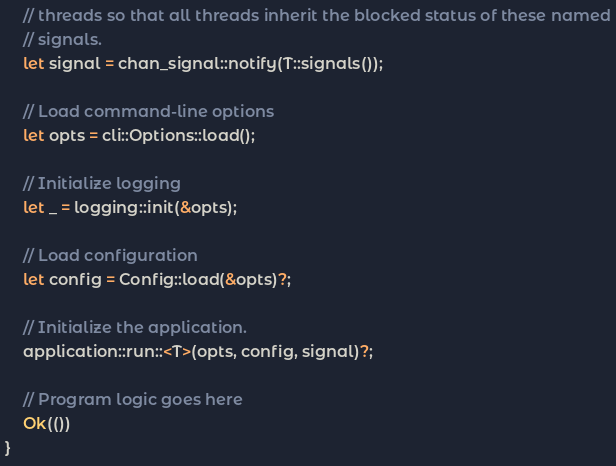<code> <loc_0><loc_0><loc_500><loc_500><_Rust_>    // threads so that all threads inherit the blocked status of these named
    // signals.
    let signal = chan_signal::notify(T::signals());

    // Load command-line options
    let opts = cli::Options::load();

    // Initialize logging
    let _ = logging::init(&opts);

    // Load configuration
    let config = Config::load(&opts)?;

    // Initialize the application.
    application::run::<T>(opts, config, signal)?;

    // Program logic goes here
    Ok(())
}
</code> 